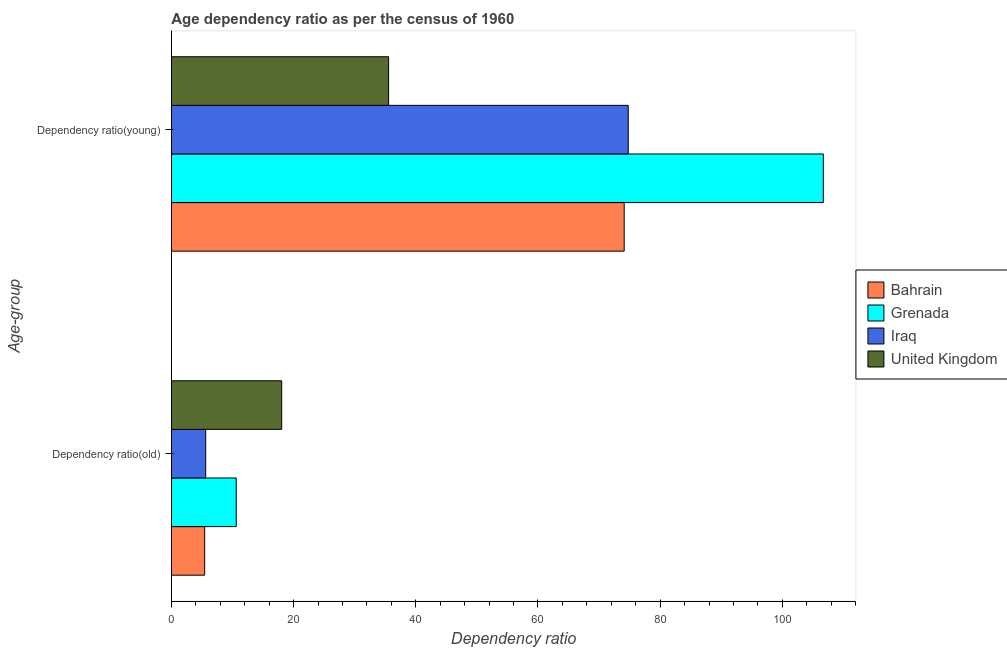How many different coloured bars are there?
Make the answer very short. 4. How many groups of bars are there?
Offer a terse response. 2. Are the number of bars per tick equal to the number of legend labels?
Give a very brief answer. Yes. Are the number of bars on each tick of the Y-axis equal?
Your response must be concise. Yes. What is the label of the 1st group of bars from the top?
Ensure brevity in your answer.  Dependency ratio(young). What is the age dependency ratio(old) in Grenada?
Provide a succinct answer. 10.61. Across all countries, what is the maximum age dependency ratio(old)?
Give a very brief answer. 18.05. Across all countries, what is the minimum age dependency ratio(young)?
Keep it short and to the point. 35.55. In which country was the age dependency ratio(young) maximum?
Give a very brief answer. Grenada. What is the total age dependency ratio(old) in the graph?
Provide a short and direct response. 39.73. What is the difference between the age dependency ratio(old) in Grenada and that in Bahrain?
Your response must be concise. 5.17. What is the difference between the age dependency ratio(old) in Iraq and the age dependency ratio(young) in United Kingdom?
Offer a terse response. -29.94. What is the average age dependency ratio(old) per country?
Your answer should be compact. 9.93. What is the difference between the age dependency ratio(old) and age dependency ratio(young) in Iraq?
Offer a very short reply. -69.16. In how many countries, is the age dependency ratio(old) greater than 84 ?
Provide a short and direct response. 0. What is the ratio of the age dependency ratio(old) in Bahrain to that in Grenada?
Your answer should be very brief. 0.51. What does the 2nd bar from the top in Dependency ratio(old) represents?
Your answer should be very brief. Iraq. What does the 4th bar from the bottom in Dependency ratio(young) represents?
Your answer should be very brief. United Kingdom. How many countries are there in the graph?
Provide a short and direct response. 4. Are the values on the major ticks of X-axis written in scientific E-notation?
Your answer should be compact. No. Does the graph contain any zero values?
Ensure brevity in your answer.  No. How are the legend labels stacked?
Your answer should be very brief. Vertical. What is the title of the graph?
Your answer should be very brief. Age dependency ratio as per the census of 1960. Does "Cambodia" appear as one of the legend labels in the graph?
Make the answer very short. No. What is the label or title of the X-axis?
Give a very brief answer. Dependency ratio. What is the label or title of the Y-axis?
Give a very brief answer. Age-group. What is the Dependency ratio of Bahrain in Dependency ratio(old)?
Keep it short and to the point. 5.45. What is the Dependency ratio of Grenada in Dependency ratio(old)?
Offer a very short reply. 10.61. What is the Dependency ratio of Iraq in Dependency ratio(old)?
Make the answer very short. 5.62. What is the Dependency ratio in United Kingdom in Dependency ratio(old)?
Keep it short and to the point. 18.05. What is the Dependency ratio in Bahrain in Dependency ratio(young)?
Your response must be concise. 74.12. What is the Dependency ratio in Grenada in Dependency ratio(young)?
Provide a succinct answer. 106.71. What is the Dependency ratio in Iraq in Dependency ratio(young)?
Provide a succinct answer. 74.78. What is the Dependency ratio of United Kingdom in Dependency ratio(young)?
Your answer should be compact. 35.55. Across all Age-group, what is the maximum Dependency ratio in Bahrain?
Offer a terse response. 74.12. Across all Age-group, what is the maximum Dependency ratio of Grenada?
Your answer should be very brief. 106.71. Across all Age-group, what is the maximum Dependency ratio of Iraq?
Ensure brevity in your answer.  74.78. Across all Age-group, what is the maximum Dependency ratio of United Kingdom?
Your answer should be very brief. 35.55. Across all Age-group, what is the minimum Dependency ratio in Bahrain?
Your answer should be compact. 5.45. Across all Age-group, what is the minimum Dependency ratio of Grenada?
Your answer should be compact. 10.61. Across all Age-group, what is the minimum Dependency ratio in Iraq?
Provide a succinct answer. 5.62. Across all Age-group, what is the minimum Dependency ratio of United Kingdom?
Your response must be concise. 18.05. What is the total Dependency ratio of Bahrain in the graph?
Provide a short and direct response. 79.56. What is the total Dependency ratio of Grenada in the graph?
Offer a very short reply. 117.32. What is the total Dependency ratio in Iraq in the graph?
Provide a succinct answer. 80.39. What is the total Dependency ratio in United Kingdom in the graph?
Offer a very short reply. 53.61. What is the difference between the Dependency ratio of Bahrain in Dependency ratio(old) and that in Dependency ratio(young)?
Offer a very short reply. -68.67. What is the difference between the Dependency ratio in Grenada in Dependency ratio(old) and that in Dependency ratio(young)?
Make the answer very short. -96.09. What is the difference between the Dependency ratio of Iraq in Dependency ratio(old) and that in Dependency ratio(young)?
Your answer should be compact. -69.16. What is the difference between the Dependency ratio of United Kingdom in Dependency ratio(old) and that in Dependency ratio(young)?
Give a very brief answer. -17.5. What is the difference between the Dependency ratio in Bahrain in Dependency ratio(old) and the Dependency ratio in Grenada in Dependency ratio(young)?
Provide a succinct answer. -101.26. What is the difference between the Dependency ratio of Bahrain in Dependency ratio(old) and the Dependency ratio of Iraq in Dependency ratio(young)?
Make the answer very short. -69.33. What is the difference between the Dependency ratio of Bahrain in Dependency ratio(old) and the Dependency ratio of United Kingdom in Dependency ratio(young)?
Offer a very short reply. -30.11. What is the difference between the Dependency ratio in Grenada in Dependency ratio(old) and the Dependency ratio in Iraq in Dependency ratio(young)?
Provide a short and direct response. -64.16. What is the difference between the Dependency ratio of Grenada in Dependency ratio(old) and the Dependency ratio of United Kingdom in Dependency ratio(young)?
Ensure brevity in your answer.  -24.94. What is the difference between the Dependency ratio in Iraq in Dependency ratio(old) and the Dependency ratio in United Kingdom in Dependency ratio(young)?
Your answer should be compact. -29.94. What is the average Dependency ratio of Bahrain per Age-group?
Offer a terse response. 39.78. What is the average Dependency ratio of Grenada per Age-group?
Provide a short and direct response. 58.66. What is the average Dependency ratio of Iraq per Age-group?
Provide a short and direct response. 40.2. What is the average Dependency ratio of United Kingdom per Age-group?
Offer a terse response. 26.8. What is the difference between the Dependency ratio of Bahrain and Dependency ratio of Grenada in Dependency ratio(old)?
Offer a very short reply. -5.17. What is the difference between the Dependency ratio of Bahrain and Dependency ratio of Iraq in Dependency ratio(old)?
Provide a short and direct response. -0.17. What is the difference between the Dependency ratio in Bahrain and Dependency ratio in United Kingdom in Dependency ratio(old)?
Make the answer very short. -12.61. What is the difference between the Dependency ratio in Grenada and Dependency ratio in Iraq in Dependency ratio(old)?
Make the answer very short. 5. What is the difference between the Dependency ratio in Grenada and Dependency ratio in United Kingdom in Dependency ratio(old)?
Offer a very short reply. -7.44. What is the difference between the Dependency ratio in Iraq and Dependency ratio in United Kingdom in Dependency ratio(old)?
Provide a succinct answer. -12.44. What is the difference between the Dependency ratio of Bahrain and Dependency ratio of Grenada in Dependency ratio(young)?
Offer a very short reply. -32.59. What is the difference between the Dependency ratio in Bahrain and Dependency ratio in Iraq in Dependency ratio(young)?
Offer a very short reply. -0.66. What is the difference between the Dependency ratio in Bahrain and Dependency ratio in United Kingdom in Dependency ratio(young)?
Make the answer very short. 38.56. What is the difference between the Dependency ratio of Grenada and Dependency ratio of Iraq in Dependency ratio(young)?
Your answer should be compact. 31.93. What is the difference between the Dependency ratio in Grenada and Dependency ratio in United Kingdom in Dependency ratio(young)?
Keep it short and to the point. 71.15. What is the difference between the Dependency ratio of Iraq and Dependency ratio of United Kingdom in Dependency ratio(young)?
Your response must be concise. 39.22. What is the ratio of the Dependency ratio in Bahrain in Dependency ratio(old) to that in Dependency ratio(young)?
Provide a short and direct response. 0.07. What is the ratio of the Dependency ratio in Grenada in Dependency ratio(old) to that in Dependency ratio(young)?
Your response must be concise. 0.1. What is the ratio of the Dependency ratio in Iraq in Dependency ratio(old) to that in Dependency ratio(young)?
Keep it short and to the point. 0.08. What is the ratio of the Dependency ratio of United Kingdom in Dependency ratio(old) to that in Dependency ratio(young)?
Ensure brevity in your answer.  0.51. What is the difference between the highest and the second highest Dependency ratio of Bahrain?
Ensure brevity in your answer.  68.67. What is the difference between the highest and the second highest Dependency ratio of Grenada?
Make the answer very short. 96.09. What is the difference between the highest and the second highest Dependency ratio in Iraq?
Make the answer very short. 69.16. What is the difference between the highest and the second highest Dependency ratio of United Kingdom?
Give a very brief answer. 17.5. What is the difference between the highest and the lowest Dependency ratio in Bahrain?
Your answer should be compact. 68.67. What is the difference between the highest and the lowest Dependency ratio in Grenada?
Provide a succinct answer. 96.09. What is the difference between the highest and the lowest Dependency ratio in Iraq?
Your response must be concise. 69.16. What is the difference between the highest and the lowest Dependency ratio in United Kingdom?
Offer a very short reply. 17.5. 